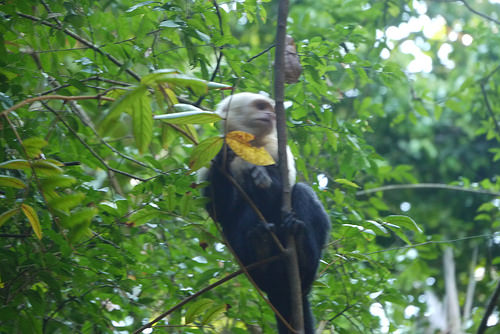<image>
Can you confirm if the cocoon is above the monkey? Yes. The cocoon is positioned above the monkey in the vertical space, higher up in the scene. 